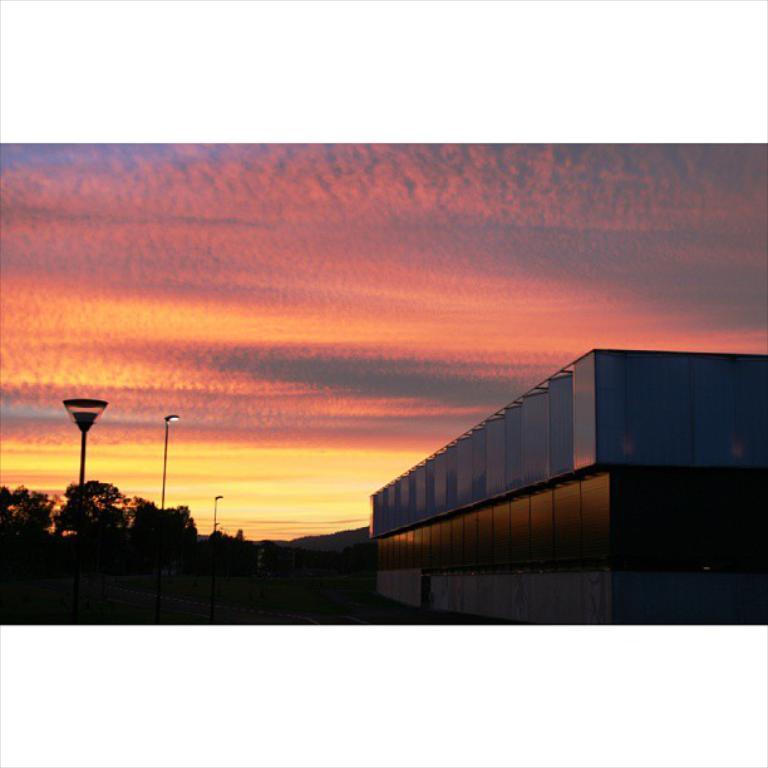Can you describe this image briefly? In this image there is a building. And there are a grass and trees. And in that grass there are light poles. At the top there is a sky. 